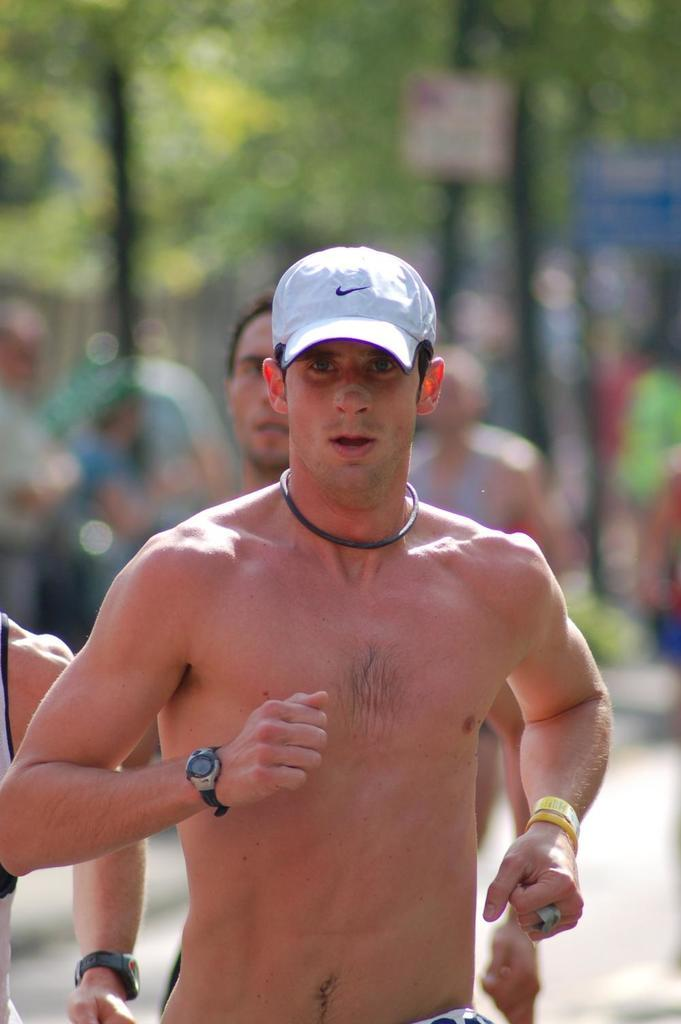How many people are in the image? There are people in the image, but the exact number is not specified. What is one person wearing in the image? One person is wearing a cap in the image. What can be seen in the background of the image? There are trees, poles, and boards in the background of the image. What type of kettle is being used by the people in the image? There is no kettle present in the image. How many weeks have passed since the people in the image last met? The image does not provide any information about the people's previous meetings or the passage of time. 